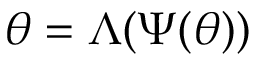Convert formula to latex. <formula><loc_0><loc_0><loc_500><loc_500>\theta = \Lambda ( \Psi ( \theta ) )</formula> 